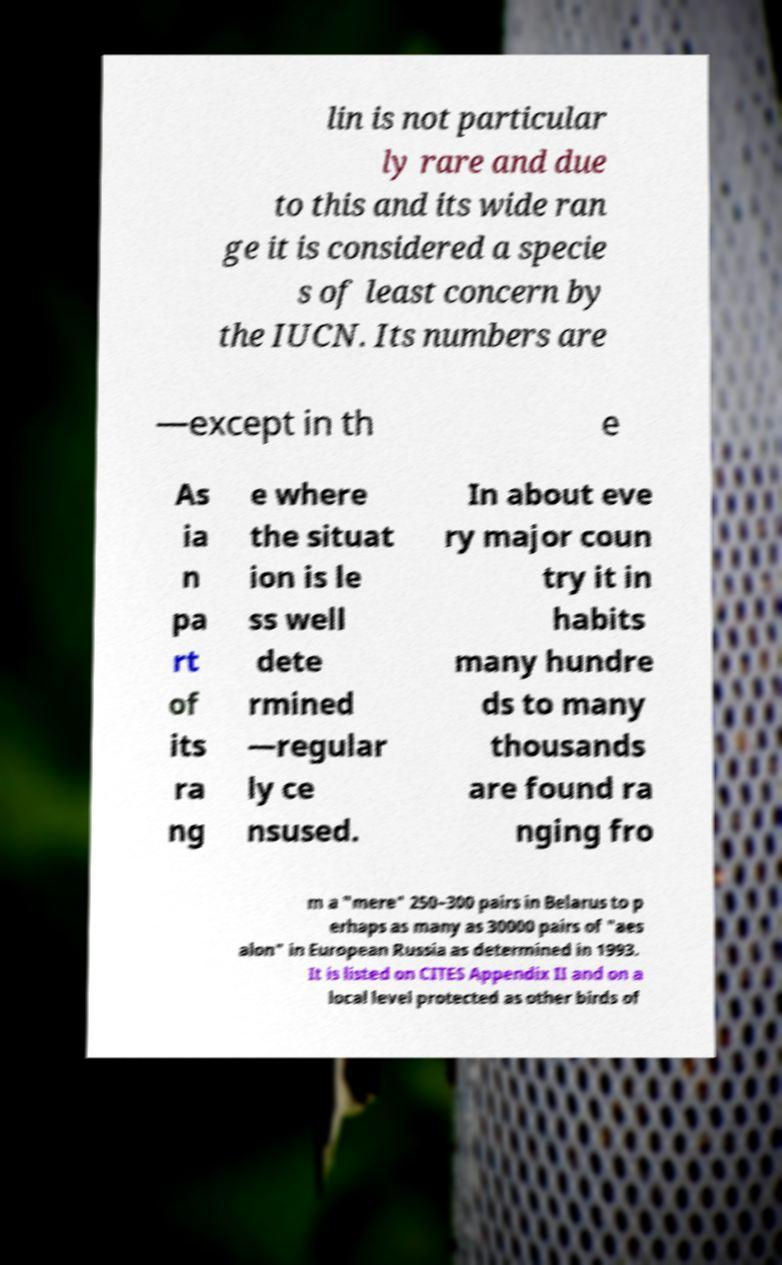Please read and relay the text visible in this image. What does it say? lin is not particular ly rare and due to this and its wide ran ge it is considered a specie s of least concern by the IUCN. Its numbers are —except in th e As ia n pa rt of its ra ng e where the situat ion is le ss well dete rmined —regular ly ce nsused. In about eve ry major coun try it in habits many hundre ds to many thousands are found ra nging fro m a "mere" 250–300 pairs in Belarus to p erhaps as many as 30000 pairs of "aes alon" in European Russia as determined in 1993. It is listed on CITES Appendix II and on a local level protected as other birds of 